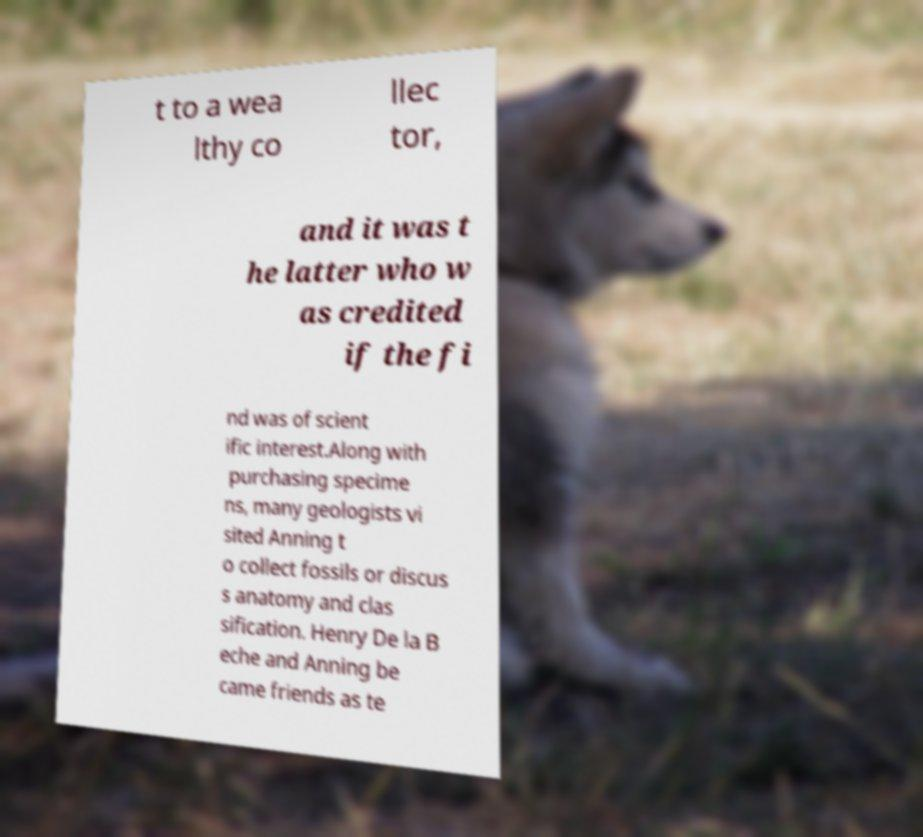I need the written content from this picture converted into text. Can you do that? t to a wea lthy co llec tor, and it was t he latter who w as credited if the fi nd was of scient ific interest.Along with purchasing specime ns, many geologists vi sited Anning t o collect fossils or discus s anatomy and clas sification. Henry De la B eche and Anning be came friends as te 